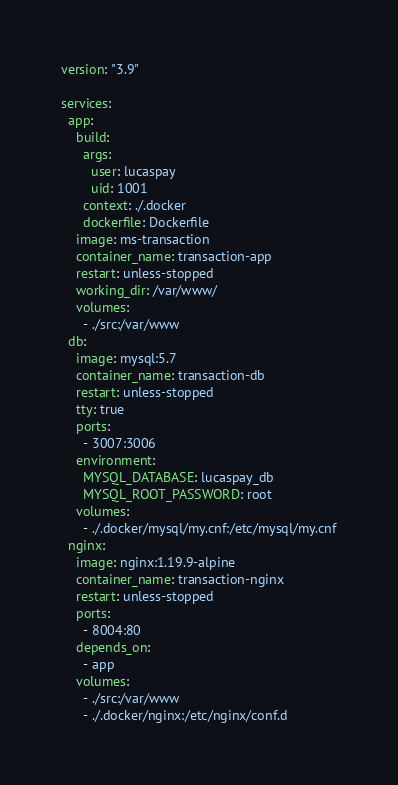Convert code to text. <code><loc_0><loc_0><loc_500><loc_500><_YAML_>version: "3.9"

services:
  app:
    build: 
      args: 
        user: lucaspay
        uid: 1001
      context: ./.docker
      dockerfile: Dockerfile
    image: ms-transaction
    container_name: transaction-app
    restart: unless-stopped
    working_dir: /var/www/
    volumes: 
      - ./src:/var/www
  db:
    image: mysql:5.7
    container_name: transaction-db
    restart: unless-stopped
    tty: true
    ports: 
      - 3007:3006
    environment: 
      MYSQL_DATABASE: lucaspay_db
      MYSQL_ROOT_PASSWORD: root
    volumes: 
      - ./.docker/mysql/my.cnf:/etc/mysql/my.cnf
  nginx:
    image: nginx:1.19.9-alpine
    container_name: transaction-nginx
    restart: unless-stopped
    ports: 
      - 8004:80
    depends_on: 
      - app
    volumes: 
      - ./src:/var/www
      - ./.docker/nginx:/etc/nginx/conf.d
</code> 